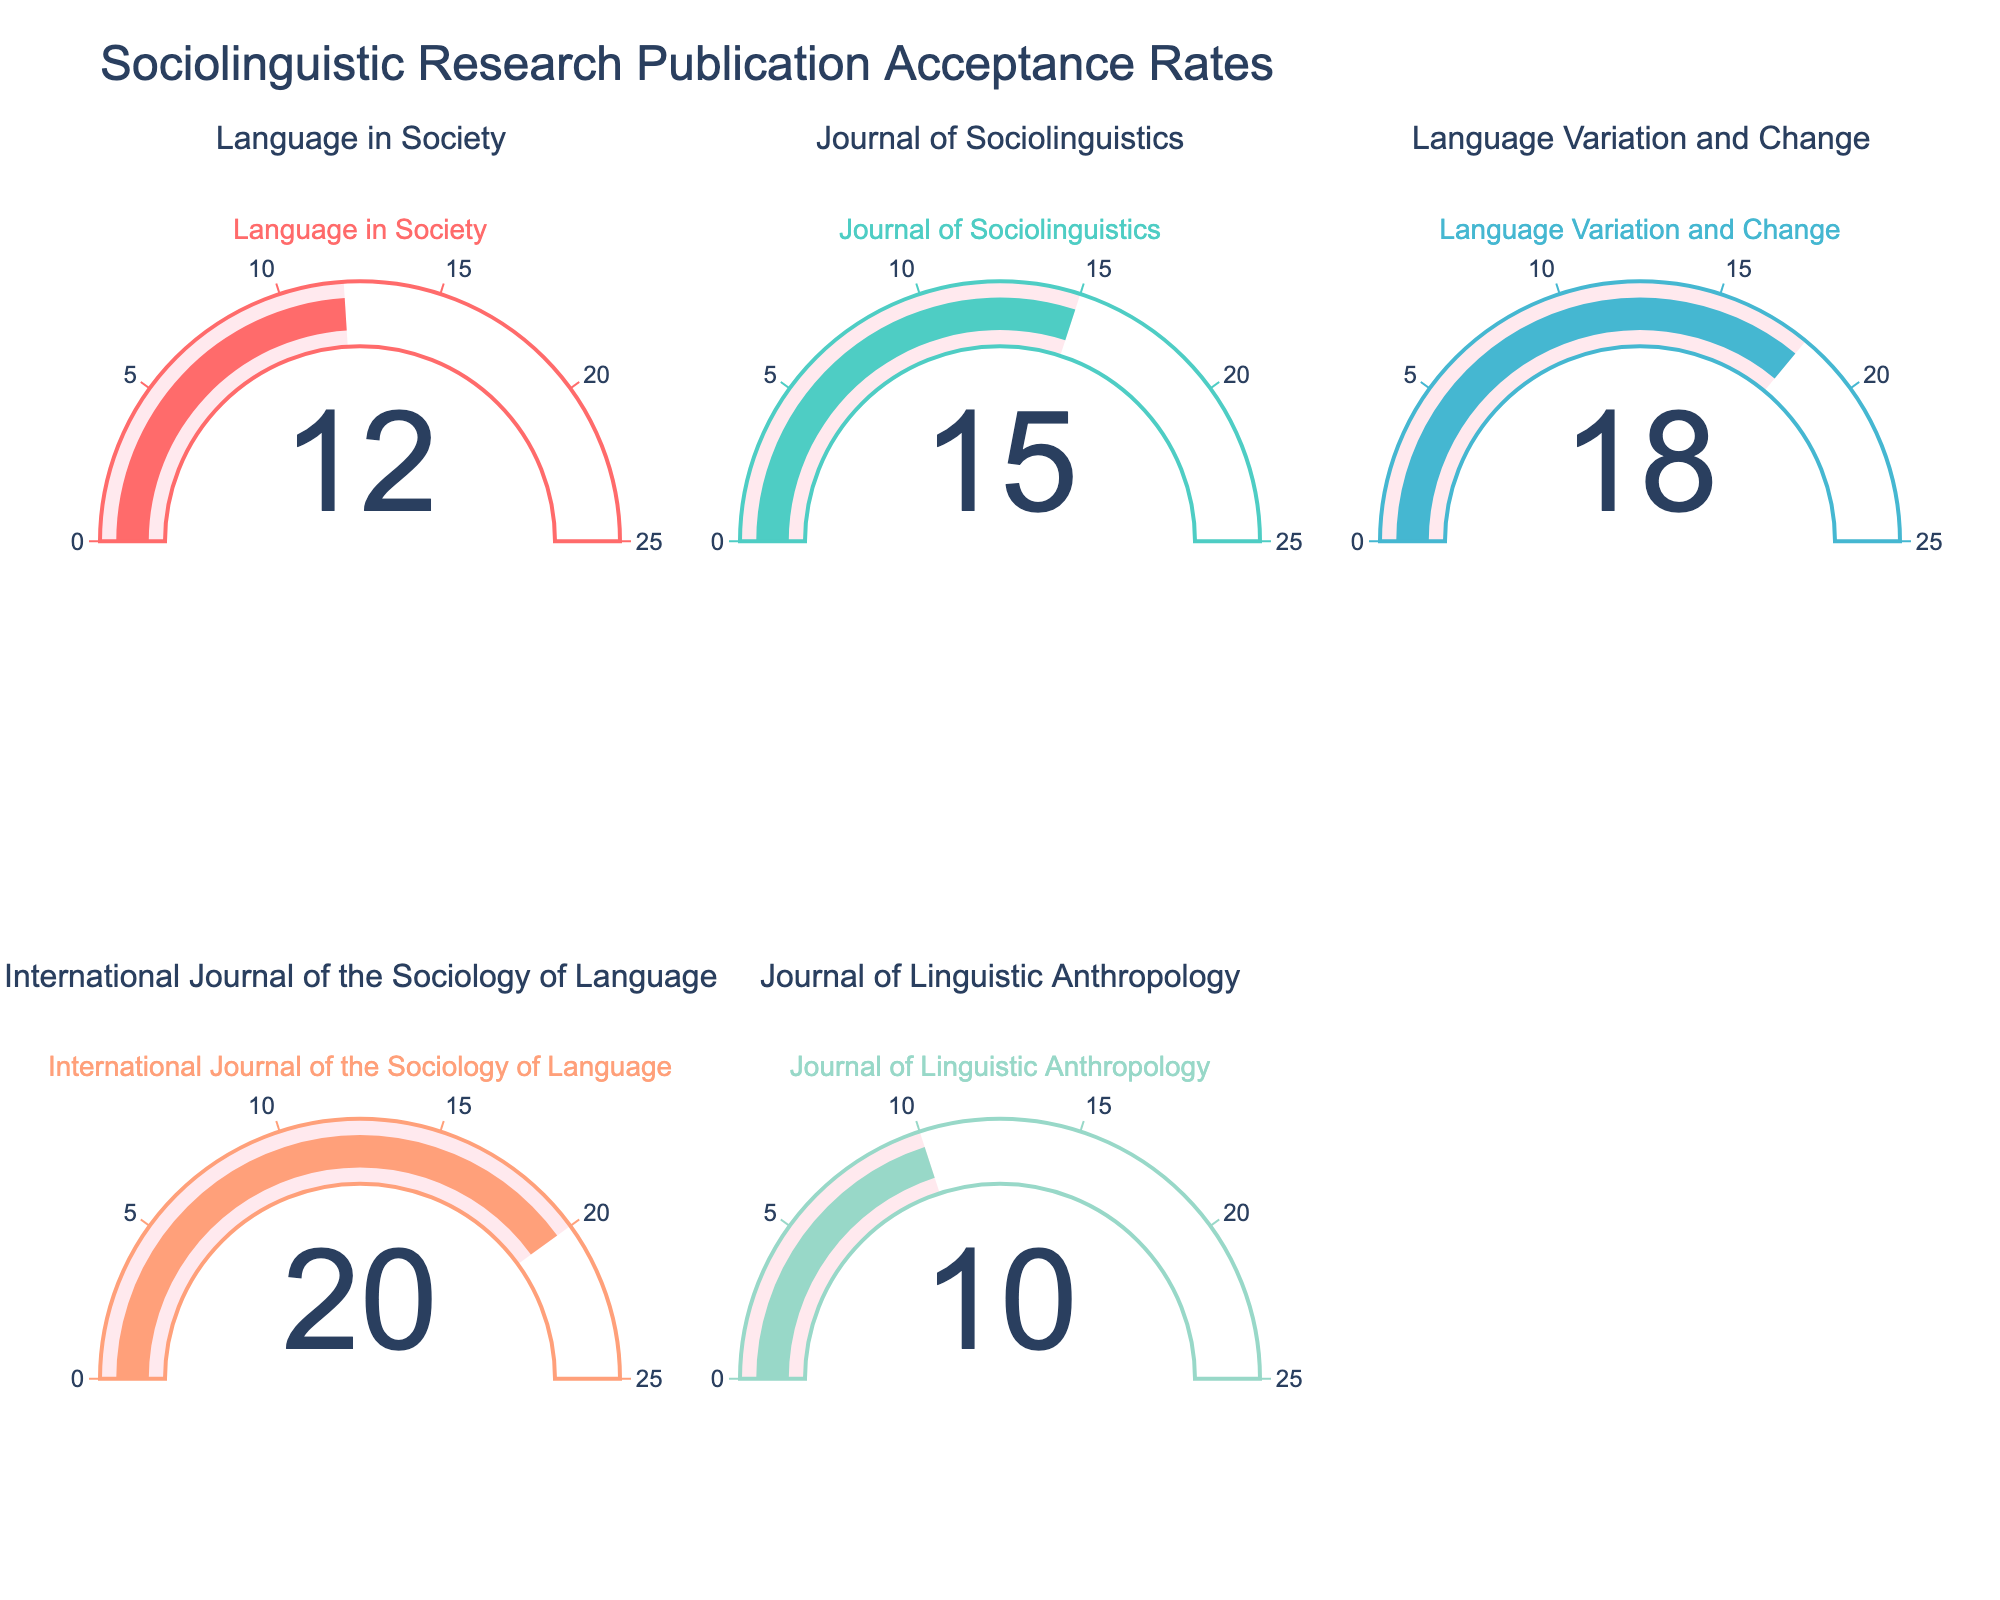How many journals are represented in the figure? The plot has five gauges, each corresponding to a different journal, indicating five journals represented.
Answer: Five Which journal has the highest acceptance rate? By inspecting all the gauges, the 'International Journal of the Sociology of Language' shows the highest acceptance rate at 20%.
Answer: International Journal of the Sociology of Language How much higher is the acceptance rate of 'Language Variation and Change' compared to 'Journal of Linguistic Anthropology'? The acceptance rate of 'Language Variation and Change' is 18%, and 'Journal of Linguistic Anthropology' is 10%. Calculate 18% - 10% = 8%.
Answer: 8% What is the average acceptance rate across all journals? Sum the acceptance rates: 12 + 15 + 18 + 20 + 10 = 75. Then divide by the number of journals (5): 75 / 5 = 15.
Answer: 15% Does any journal have an acceptance rate below 12%? The 'Journal of Linguistic Anthropology' has a 10% acceptance rate, which is below 12%.
Answer: Yes Which journal has an acceptance rate closest to 15%? The 'Journal of Sociolinguistics' has an acceptance rate of 15%, which matches exactly.
Answer: Journal of Sociolinguistics How does the acceptance rate of 'Language in Society' compare to the average acceptance rate? The acceptance rate of 'Language in Society' is 12%, while the average is 15%. Since 12% is less than 15%, it is below the average.
Answer: Below What is the range of acceptance rates across the journals? The highest acceptance rate is 20% ('International Journal of the Sociology of Language') and the lowest is 10% ('Journal of Linguistic Anthropology'). Calculate 20% - 10% = 10%.
Answer: 10% If a new journal is added with an acceptance rate of 25%, how will this affect the average acceptance rate? The current total acceptance rate is 75% for 5 journals. Adding a 25% acceptance rate increases the total to 100%. The new average is 100 / 6 = 16.67%.
Answer: 16.67% Which journals have acceptance rates that are within 5% of each other? The 'Language in Society' (12%) and 'Journal of Sociolinguistics' (15%) have a difference of 3%. 'Journal of Sociolinguistics' (15%) and 'Language Variation and Change' (18%) have a difference of 3%.
Answer: Language in Society and Journal of Sociolinguistics; Journal of Sociolinguistics and Language Variation and Change 